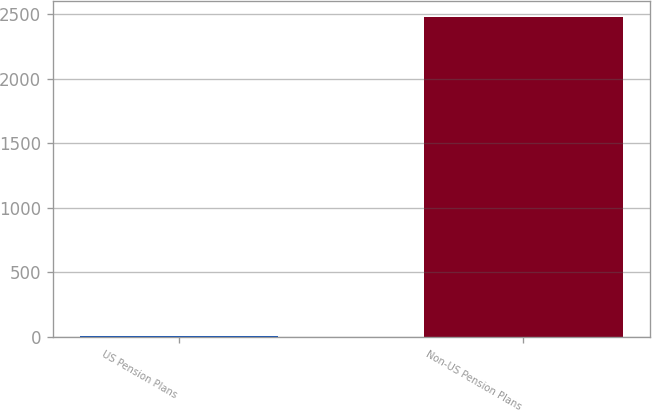<chart> <loc_0><loc_0><loc_500><loc_500><bar_chart><fcel>US Pension Plans<fcel>Non-US Pension Plans<nl><fcel>5<fcel>2478<nl></chart> 